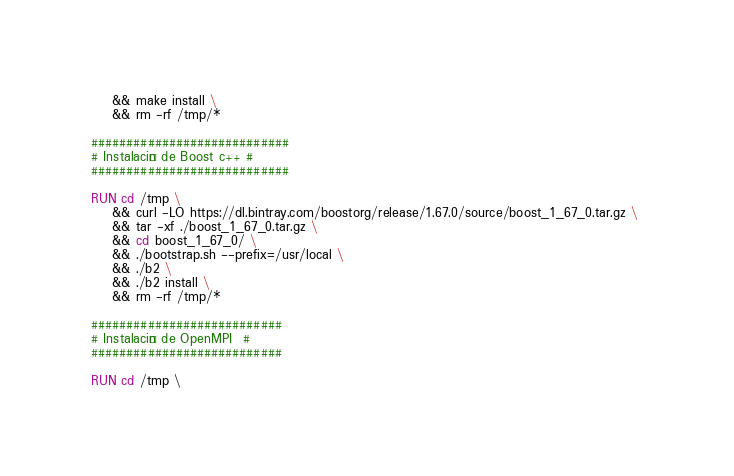Convert code to text. <code><loc_0><loc_0><loc_500><loc_500><_Dockerfile_>	&& make install \
	&& rm -rf /tmp/*

############################
# Instalación de Boost c++ #
############################

RUN cd /tmp \ 
	&& curl -LO https://dl.bintray.com/boostorg/release/1.67.0/source/boost_1_67_0.tar.gz \ 
	&& tar -xf ./boost_1_67_0.tar.gz \
	&& cd boost_1_67_0/ \
	&& ./bootstrap.sh --prefix=/usr/local \
	&& ./b2 \
	&& ./b2 install \
	&& rm -rf /tmp/*

###########################
# Instalación de OpenMPI  #
###########################

RUN cd /tmp \</code> 